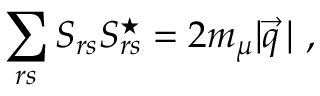<formula> <loc_0><loc_0><loc_500><loc_500>\sum _ { r s } S _ { r s } S _ { r s } ^ { ^ { * } } = 2 m _ { \mu } | \vec { q } \, | \ ,</formula> 